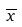Convert formula to latex. <formula><loc_0><loc_0><loc_500><loc_500>\overline { x }</formula> 